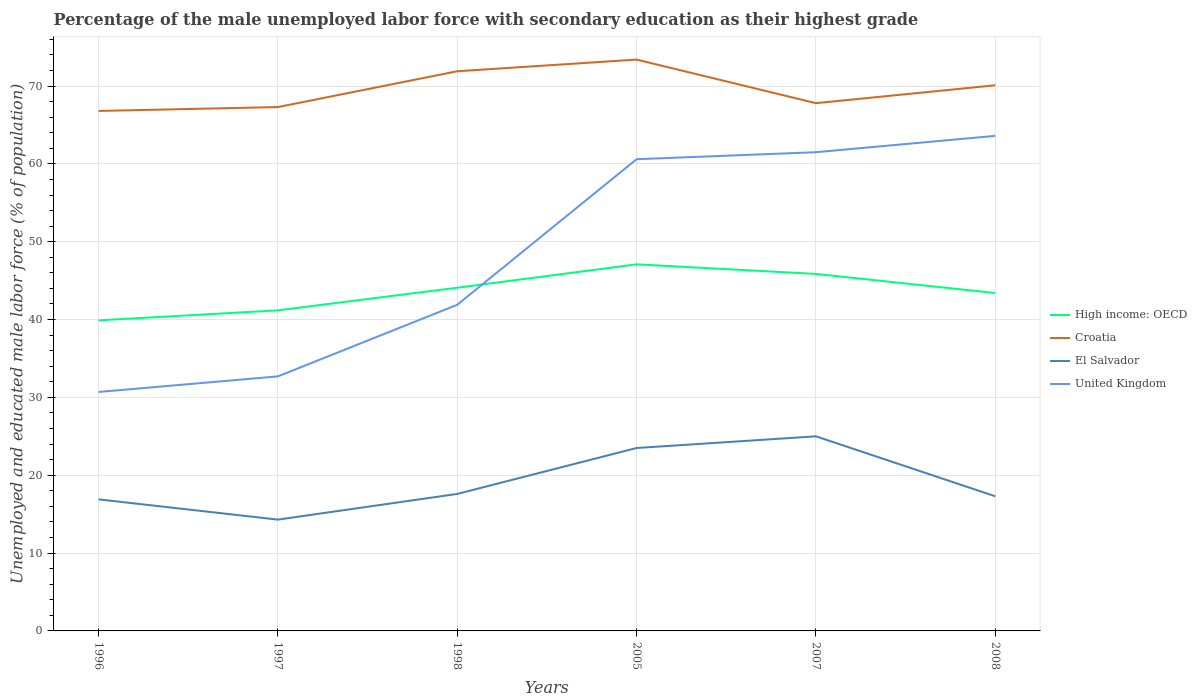How many different coloured lines are there?
Provide a short and direct response. 4. Does the line corresponding to High income: OECD intersect with the line corresponding to United Kingdom?
Your response must be concise. Yes. Is the number of lines equal to the number of legend labels?
Offer a very short reply. Yes. Across all years, what is the maximum percentage of the unemployed male labor force with secondary education in El Salvador?
Your answer should be compact. 14.3. What is the total percentage of the unemployed male labor force with secondary education in High income: OECD in the graph?
Ensure brevity in your answer.  -4.68. What is the difference between the highest and the second highest percentage of the unemployed male labor force with secondary education in High income: OECD?
Keep it short and to the point. 7.19. What is the difference between the highest and the lowest percentage of the unemployed male labor force with secondary education in United Kingdom?
Your answer should be compact. 3. How many lines are there?
Keep it short and to the point. 4. How many years are there in the graph?
Your answer should be compact. 6. Are the values on the major ticks of Y-axis written in scientific E-notation?
Your answer should be very brief. No. Does the graph contain grids?
Provide a short and direct response. Yes. How many legend labels are there?
Your answer should be compact. 4. How are the legend labels stacked?
Keep it short and to the point. Vertical. What is the title of the graph?
Offer a terse response. Percentage of the male unemployed labor force with secondary education as their highest grade. What is the label or title of the Y-axis?
Provide a short and direct response. Unemployed and educated male labor force (% of population). What is the Unemployed and educated male labor force (% of population) in High income: OECD in 1996?
Make the answer very short. 39.9. What is the Unemployed and educated male labor force (% of population) of Croatia in 1996?
Make the answer very short. 66.8. What is the Unemployed and educated male labor force (% of population) of El Salvador in 1996?
Make the answer very short. 16.9. What is the Unemployed and educated male labor force (% of population) in United Kingdom in 1996?
Your response must be concise. 30.7. What is the Unemployed and educated male labor force (% of population) in High income: OECD in 1997?
Offer a very short reply. 41.18. What is the Unemployed and educated male labor force (% of population) in Croatia in 1997?
Your answer should be compact. 67.3. What is the Unemployed and educated male labor force (% of population) in El Salvador in 1997?
Provide a succinct answer. 14.3. What is the Unemployed and educated male labor force (% of population) in United Kingdom in 1997?
Your answer should be very brief. 32.7. What is the Unemployed and educated male labor force (% of population) in High income: OECD in 1998?
Give a very brief answer. 44.09. What is the Unemployed and educated male labor force (% of population) in Croatia in 1998?
Keep it short and to the point. 71.9. What is the Unemployed and educated male labor force (% of population) of El Salvador in 1998?
Provide a short and direct response. 17.6. What is the Unemployed and educated male labor force (% of population) in United Kingdom in 1998?
Make the answer very short. 41.9. What is the Unemployed and educated male labor force (% of population) in High income: OECD in 2005?
Make the answer very short. 47.1. What is the Unemployed and educated male labor force (% of population) of Croatia in 2005?
Ensure brevity in your answer.  73.4. What is the Unemployed and educated male labor force (% of population) in El Salvador in 2005?
Provide a succinct answer. 23.5. What is the Unemployed and educated male labor force (% of population) of United Kingdom in 2005?
Ensure brevity in your answer.  60.6. What is the Unemployed and educated male labor force (% of population) of High income: OECD in 2007?
Give a very brief answer. 45.86. What is the Unemployed and educated male labor force (% of population) in Croatia in 2007?
Keep it short and to the point. 67.8. What is the Unemployed and educated male labor force (% of population) of United Kingdom in 2007?
Your answer should be very brief. 61.5. What is the Unemployed and educated male labor force (% of population) of High income: OECD in 2008?
Keep it short and to the point. 43.41. What is the Unemployed and educated male labor force (% of population) in Croatia in 2008?
Your answer should be very brief. 70.1. What is the Unemployed and educated male labor force (% of population) of El Salvador in 2008?
Make the answer very short. 17.3. What is the Unemployed and educated male labor force (% of population) in United Kingdom in 2008?
Offer a terse response. 63.6. Across all years, what is the maximum Unemployed and educated male labor force (% of population) in High income: OECD?
Keep it short and to the point. 47.1. Across all years, what is the maximum Unemployed and educated male labor force (% of population) in Croatia?
Your answer should be compact. 73.4. Across all years, what is the maximum Unemployed and educated male labor force (% of population) of United Kingdom?
Offer a very short reply. 63.6. Across all years, what is the minimum Unemployed and educated male labor force (% of population) of High income: OECD?
Keep it short and to the point. 39.9. Across all years, what is the minimum Unemployed and educated male labor force (% of population) of Croatia?
Your response must be concise. 66.8. Across all years, what is the minimum Unemployed and educated male labor force (% of population) in El Salvador?
Provide a succinct answer. 14.3. Across all years, what is the minimum Unemployed and educated male labor force (% of population) of United Kingdom?
Keep it short and to the point. 30.7. What is the total Unemployed and educated male labor force (% of population) of High income: OECD in the graph?
Your response must be concise. 261.55. What is the total Unemployed and educated male labor force (% of population) in Croatia in the graph?
Your response must be concise. 417.3. What is the total Unemployed and educated male labor force (% of population) of El Salvador in the graph?
Your answer should be very brief. 114.6. What is the total Unemployed and educated male labor force (% of population) of United Kingdom in the graph?
Your answer should be compact. 291. What is the difference between the Unemployed and educated male labor force (% of population) in High income: OECD in 1996 and that in 1997?
Give a very brief answer. -1.28. What is the difference between the Unemployed and educated male labor force (% of population) in El Salvador in 1996 and that in 1997?
Your answer should be compact. 2.6. What is the difference between the Unemployed and educated male labor force (% of population) in United Kingdom in 1996 and that in 1997?
Your answer should be compact. -2. What is the difference between the Unemployed and educated male labor force (% of population) in High income: OECD in 1996 and that in 1998?
Provide a short and direct response. -4.19. What is the difference between the Unemployed and educated male labor force (% of population) in Croatia in 1996 and that in 1998?
Ensure brevity in your answer.  -5.1. What is the difference between the Unemployed and educated male labor force (% of population) in High income: OECD in 1996 and that in 2005?
Keep it short and to the point. -7.19. What is the difference between the Unemployed and educated male labor force (% of population) in Croatia in 1996 and that in 2005?
Offer a very short reply. -6.6. What is the difference between the Unemployed and educated male labor force (% of population) in El Salvador in 1996 and that in 2005?
Offer a terse response. -6.6. What is the difference between the Unemployed and educated male labor force (% of population) in United Kingdom in 1996 and that in 2005?
Ensure brevity in your answer.  -29.9. What is the difference between the Unemployed and educated male labor force (% of population) in High income: OECD in 1996 and that in 2007?
Provide a succinct answer. -5.96. What is the difference between the Unemployed and educated male labor force (% of population) in Croatia in 1996 and that in 2007?
Give a very brief answer. -1. What is the difference between the Unemployed and educated male labor force (% of population) of El Salvador in 1996 and that in 2007?
Offer a very short reply. -8.1. What is the difference between the Unemployed and educated male labor force (% of population) in United Kingdom in 1996 and that in 2007?
Your answer should be very brief. -30.8. What is the difference between the Unemployed and educated male labor force (% of population) in High income: OECD in 1996 and that in 2008?
Your answer should be compact. -3.51. What is the difference between the Unemployed and educated male labor force (% of population) in Croatia in 1996 and that in 2008?
Provide a succinct answer. -3.3. What is the difference between the Unemployed and educated male labor force (% of population) in United Kingdom in 1996 and that in 2008?
Provide a succinct answer. -32.9. What is the difference between the Unemployed and educated male labor force (% of population) of High income: OECD in 1997 and that in 1998?
Your response must be concise. -2.91. What is the difference between the Unemployed and educated male labor force (% of population) in Croatia in 1997 and that in 1998?
Give a very brief answer. -4.6. What is the difference between the Unemployed and educated male labor force (% of population) in El Salvador in 1997 and that in 1998?
Give a very brief answer. -3.3. What is the difference between the Unemployed and educated male labor force (% of population) in United Kingdom in 1997 and that in 1998?
Make the answer very short. -9.2. What is the difference between the Unemployed and educated male labor force (% of population) in High income: OECD in 1997 and that in 2005?
Give a very brief answer. -5.91. What is the difference between the Unemployed and educated male labor force (% of population) of El Salvador in 1997 and that in 2005?
Your response must be concise. -9.2. What is the difference between the Unemployed and educated male labor force (% of population) in United Kingdom in 1997 and that in 2005?
Your answer should be very brief. -27.9. What is the difference between the Unemployed and educated male labor force (% of population) in High income: OECD in 1997 and that in 2007?
Your answer should be compact. -4.68. What is the difference between the Unemployed and educated male labor force (% of population) of El Salvador in 1997 and that in 2007?
Make the answer very short. -10.7. What is the difference between the Unemployed and educated male labor force (% of population) of United Kingdom in 1997 and that in 2007?
Provide a short and direct response. -28.8. What is the difference between the Unemployed and educated male labor force (% of population) in High income: OECD in 1997 and that in 2008?
Keep it short and to the point. -2.23. What is the difference between the Unemployed and educated male labor force (% of population) in El Salvador in 1997 and that in 2008?
Provide a short and direct response. -3. What is the difference between the Unemployed and educated male labor force (% of population) in United Kingdom in 1997 and that in 2008?
Offer a very short reply. -30.9. What is the difference between the Unemployed and educated male labor force (% of population) in High income: OECD in 1998 and that in 2005?
Your response must be concise. -3. What is the difference between the Unemployed and educated male labor force (% of population) of United Kingdom in 1998 and that in 2005?
Your answer should be compact. -18.7. What is the difference between the Unemployed and educated male labor force (% of population) of High income: OECD in 1998 and that in 2007?
Ensure brevity in your answer.  -1.77. What is the difference between the Unemployed and educated male labor force (% of population) in United Kingdom in 1998 and that in 2007?
Make the answer very short. -19.6. What is the difference between the Unemployed and educated male labor force (% of population) of High income: OECD in 1998 and that in 2008?
Provide a succinct answer. 0.68. What is the difference between the Unemployed and educated male labor force (% of population) in El Salvador in 1998 and that in 2008?
Keep it short and to the point. 0.3. What is the difference between the Unemployed and educated male labor force (% of population) in United Kingdom in 1998 and that in 2008?
Keep it short and to the point. -21.7. What is the difference between the Unemployed and educated male labor force (% of population) in High income: OECD in 2005 and that in 2007?
Offer a terse response. 1.23. What is the difference between the Unemployed and educated male labor force (% of population) of Croatia in 2005 and that in 2007?
Make the answer very short. 5.6. What is the difference between the Unemployed and educated male labor force (% of population) of El Salvador in 2005 and that in 2007?
Your answer should be very brief. -1.5. What is the difference between the Unemployed and educated male labor force (% of population) in United Kingdom in 2005 and that in 2007?
Provide a succinct answer. -0.9. What is the difference between the Unemployed and educated male labor force (% of population) of High income: OECD in 2005 and that in 2008?
Provide a succinct answer. 3.68. What is the difference between the Unemployed and educated male labor force (% of population) in El Salvador in 2005 and that in 2008?
Ensure brevity in your answer.  6.2. What is the difference between the Unemployed and educated male labor force (% of population) of United Kingdom in 2005 and that in 2008?
Provide a short and direct response. -3. What is the difference between the Unemployed and educated male labor force (% of population) in High income: OECD in 2007 and that in 2008?
Provide a short and direct response. 2.45. What is the difference between the Unemployed and educated male labor force (% of population) in El Salvador in 2007 and that in 2008?
Give a very brief answer. 7.7. What is the difference between the Unemployed and educated male labor force (% of population) in High income: OECD in 1996 and the Unemployed and educated male labor force (% of population) in Croatia in 1997?
Make the answer very short. -27.4. What is the difference between the Unemployed and educated male labor force (% of population) of High income: OECD in 1996 and the Unemployed and educated male labor force (% of population) of El Salvador in 1997?
Your response must be concise. 25.6. What is the difference between the Unemployed and educated male labor force (% of population) of High income: OECD in 1996 and the Unemployed and educated male labor force (% of population) of United Kingdom in 1997?
Provide a succinct answer. 7.2. What is the difference between the Unemployed and educated male labor force (% of population) of Croatia in 1996 and the Unemployed and educated male labor force (% of population) of El Salvador in 1997?
Provide a short and direct response. 52.5. What is the difference between the Unemployed and educated male labor force (% of population) in Croatia in 1996 and the Unemployed and educated male labor force (% of population) in United Kingdom in 1997?
Ensure brevity in your answer.  34.1. What is the difference between the Unemployed and educated male labor force (% of population) of El Salvador in 1996 and the Unemployed and educated male labor force (% of population) of United Kingdom in 1997?
Your answer should be compact. -15.8. What is the difference between the Unemployed and educated male labor force (% of population) of High income: OECD in 1996 and the Unemployed and educated male labor force (% of population) of Croatia in 1998?
Your answer should be compact. -32. What is the difference between the Unemployed and educated male labor force (% of population) in High income: OECD in 1996 and the Unemployed and educated male labor force (% of population) in El Salvador in 1998?
Provide a succinct answer. 22.3. What is the difference between the Unemployed and educated male labor force (% of population) of High income: OECD in 1996 and the Unemployed and educated male labor force (% of population) of United Kingdom in 1998?
Keep it short and to the point. -2. What is the difference between the Unemployed and educated male labor force (% of population) in Croatia in 1996 and the Unemployed and educated male labor force (% of population) in El Salvador in 1998?
Make the answer very short. 49.2. What is the difference between the Unemployed and educated male labor force (% of population) in Croatia in 1996 and the Unemployed and educated male labor force (% of population) in United Kingdom in 1998?
Provide a short and direct response. 24.9. What is the difference between the Unemployed and educated male labor force (% of population) in El Salvador in 1996 and the Unemployed and educated male labor force (% of population) in United Kingdom in 1998?
Offer a terse response. -25. What is the difference between the Unemployed and educated male labor force (% of population) of High income: OECD in 1996 and the Unemployed and educated male labor force (% of population) of Croatia in 2005?
Make the answer very short. -33.5. What is the difference between the Unemployed and educated male labor force (% of population) of High income: OECD in 1996 and the Unemployed and educated male labor force (% of population) of El Salvador in 2005?
Make the answer very short. 16.4. What is the difference between the Unemployed and educated male labor force (% of population) in High income: OECD in 1996 and the Unemployed and educated male labor force (% of population) in United Kingdom in 2005?
Your answer should be very brief. -20.7. What is the difference between the Unemployed and educated male labor force (% of population) of Croatia in 1996 and the Unemployed and educated male labor force (% of population) of El Salvador in 2005?
Your response must be concise. 43.3. What is the difference between the Unemployed and educated male labor force (% of population) of Croatia in 1996 and the Unemployed and educated male labor force (% of population) of United Kingdom in 2005?
Your answer should be very brief. 6.2. What is the difference between the Unemployed and educated male labor force (% of population) of El Salvador in 1996 and the Unemployed and educated male labor force (% of population) of United Kingdom in 2005?
Offer a terse response. -43.7. What is the difference between the Unemployed and educated male labor force (% of population) in High income: OECD in 1996 and the Unemployed and educated male labor force (% of population) in Croatia in 2007?
Provide a short and direct response. -27.9. What is the difference between the Unemployed and educated male labor force (% of population) in High income: OECD in 1996 and the Unemployed and educated male labor force (% of population) in El Salvador in 2007?
Ensure brevity in your answer.  14.9. What is the difference between the Unemployed and educated male labor force (% of population) in High income: OECD in 1996 and the Unemployed and educated male labor force (% of population) in United Kingdom in 2007?
Provide a short and direct response. -21.6. What is the difference between the Unemployed and educated male labor force (% of population) in Croatia in 1996 and the Unemployed and educated male labor force (% of population) in El Salvador in 2007?
Keep it short and to the point. 41.8. What is the difference between the Unemployed and educated male labor force (% of population) in El Salvador in 1996 and the Unemployed and educated male labor force (% of population) in United Kingdom in 2007?
Your answer should be compact. -44.6. What is the difference between the Unemployed and educated male labor force (% of population) of High income: OECD in 1996 and the Unemployed and educated male labor force (% of population) of Croatia in 2008?
Your answer should be compact. -30.2. What is the difference between the Unemployed and educated male labor force (% of population) in High income: OECD in 1996 and the Unemployed and educated male labor force (% of population) in El Salvador in 2008?
Provide a succinct answer. 22.6. What is the difference between the Unemployed and educated male labor force (% of population) in High income: OECD in 1996 and the Unemployed and educated male labor force (% of population) in United Kingdom in 2008?
Your response must be concise. -23.7. What is the difference between the Unemployed and educated male labor force (% of population) in Croatia in 1996 and the Unemployed and educated male labor force (% of population) in El Salvador in 2008?
Your answer should be very brief. 49.5. What is the difference between the Unemployed and educated male labor force (% of population) of El Salvador in 1996 and the Unemployed and educated male labor force (% of population) of United Kingdom in 2008?
Offer a terse response. -46.7. What is the difference between the Unemployed and educated male labor force (% of population) of High income: OECD in 1997 and the Unemployed and educated male labor force (% of population) of Croatia in 1998?
Provide a succinct answer. -30.72. What is the difference between the Unemployed and educated male labor force (% of population) in High income: OECD in 1997 and the Unemployed and educated male labor force (% of population) in El Salvador in 1998?
Keep it short and to the point. 23.58. What is the difference between the Unemployed and educated male labor force (% of population) of High income: OECD in 1997 and the Unemployed and educated male labor force (% of population) of United Kingdom in 1998?
Offer a very short reply. -0.72. What is the difference between the Unemployed and educated male labor force (% of population) in Croatia in 1997 and the Unemployed and educated male labor force (% of population) in El Salvador in 1998?
Your answer should be compact. 49.7. What is the difference between the Unemployed and educated male labor force (% of population) of Croatia in 1997 and the Unemployed and educated male labor force (% of population) of United Kingdom in 1998?
Offer a terse response. 25.4. What is the difference between the Unemployed and educated male labor force (% of population) in El Salvador in 1997 and the Unemployed and educated male labor force (% of population) in United Kingdom in 1998?
Provide a short and direct response. -27.6. What is the difference between the Unemployed and educated male labor force (% of population) of High income: OECD in 1997 and the Unemployed and educated male labor force (% of population) of Croatia in 2005?
Your response must be concise. -32.22. What is the difference between the Unemployed and educated male labor force (% of population) in High income: OECD in 1997 and the Unemployed and educated male labor force (% of population) in El Salvador in 2005?
Offer a very short reply. 17.68. What is the difference between the Unemployed and educated male labor force (% of population) in High income: OECD in 1997 and the Unemployed and educated male labor force (% of population) in United Kingdom in 2005?
Your response must be concise. -19.42. What is the difference between the Unemployed and educated male labor force (% of population) in Croatia in 1997 and the Unemployed and educated male labor force (% of population) in El Salvador in 2005?
Keep it short and to the point. 43.8. What is the difference between the Unemployed and educated male labor force (% of population) of Croatia in 1997 and the Unemployed and educated male labor force (% of population) of United Kingdom in 2005?
Offer a very short reply. 6.7. What is the difference between the Unemployed and educated male labor force (% of population) in El Salvador in 1997 and the Unemployed and educated male labor force (% of population) in United Kingdom in 2005?
Your answer should be very brief. -46.3. What is the difference between the Unemployed and educated male labor force (% of population) of High income: OECD in 1997 and the Unemployed and educated male labor force (% of population) of Croatia in 2007?
Make the answer very short. -26.62. What is the difference between the Unemployed and educated male labor force (% of population) in High income: OECD in 1997 and the Unemployed and educated male labor force (% of population) in El Salvador in 2007?
Your answer should be compact. 16.18. What is the difference between the Unemployed and educated male labor force (% of population) in High income: OECD in 1997 and the Unemployed and educated male labor force (% of population) in United Kingdom in 2007?
Your answer should be compact. -20.32. What is the difference between the Unemployed and educated male labor force (% of population) of Croatia in 1997 and the Unemployed and educated male labor force (% of population) of El Salvador in 2007?
Offer a very short reply. 42.3. What is the difference between the Unemployed and educated male labor force (% of population) in Croatia in 1997 and the Unemployed and educated male labor force (% of population) in United Kingdom in 2007?
Your answer should be compact. 5.8. What is the difference between the Unemployed and educated male labor force (% of population) in El Salvador in 1997 and the Unemployed and educated male labor force (% of population) in United Kingdom in 2007?
Keep it short and to the point. -47.2. What is the difference between the Unemployed and educated male labor force (% of population) of High income: OECD in 1997 and the Unemployed and educated male labor force (% of population) of Croatia in 2008?
Ensure brevity in your answer.  -28.92. What is the difference between the Unemployed and educated male labor force (% of population) of High income: OECD in 1997 and the Unemployed and educated male labor force (% of population) of El Salvador in 2008?
Your answer should be compact. 23.88. What is the difference between the Unemployed and educated male labor force (% of population) of High income: OECD in 1997 and the Unemployed and educated male labor force (% of population) of United Kingdom in 2008?
Keep it short and to the point. -22.42. What is the difference between the Unemployed and educated male labor force (% of population) of El Salvador in 1997 and the Unemployed and educated male labor force (% of population) of United Kingdom in 2008?
Offer a very short reply. -49.3. What is the difference between the Unemployed and educated male labor force (% of population) of High income: OECD in 1998 and the Unemployed and educated male labor force (% of population) of Croatia in 2005?
Provide a short and direct response. -29.31. What is the difference between the Unemployed and educated male labor force (% of population) of High income: OECD in 1998 and the Unemployed and educated male labor force (% of population) of El Salvador in 2005?
Provide a short and direct response. 20.59. What is the difference between the Unemployed and educated male labor force (% of population) of High income: OECD in 1998 and the Unemployed and educated male labor force (% of population) of United Kingdom in 2005?
Offer a terse response. -16.51. What is the difference between the Unemployed and educated male labor force (% of population) of Croatia in 1998 and the Unemployed and educated male labor force (% of population) of El Salvador in 2005?
Give a very brief answer. 48.4. What is the difference between the Unemployed and educated male labor force (% of population) of Croatia in 1998 and the Unemployed and educated male labor force (% of population) of United Kingdom in 2005?
Provide a succinct answer. 11.3. What is the difference between the Unemployed and educated male labor force (% of population) of El Salvador in 1998 and the Unemployed and educated male labor force (% of population) of United Kingdom in 2005?
Offer a very short reply. -43. What is the difference between the Unemployed and educated male labor force (% of population) in High income: OECD in 1998 and the Unemployed and educated male labor force (% of population) in Croatia in 2007?
Your answer should be compact. -23.71. What is the difference between the Unemployed and educated male labor force (% of population) of High income: OECD in 1998 and the Unemployed and educated male labor force (% of population) of El Salvador in 2007?
Make the answer very short. 19.09. What is the difference between the Unemployed and educated male labor force (% of population) of High income: OECD in 1998 and the Unemployed and educated male labor force (% of population) of United Kingdom in 2007?
Provide a succinct answer. -17.41. What is the difference between the Unemployed and educated male labor force (% of population) in Croatia in 1998 and the Unemployed and educated male labor force (% of population) in El Salvador in 2007?
Keep it short and to the point. 46.9. What is the difference between the Unemployed and educated male labor force (% of population) of Croatia in 1998 and the Unemployed and educated male labor force (% of population) of United Kingdom in 2007?
Make the answer very short. 10.4. What is the difference between the Unemployed and educated male labor force (% of population) in El Salvador in 1998 and the Unemployed and educated male labor force (% of population) in United Kingdom in 2007?
Offer a terse response. -43.9. What is the difference between the Unemployed and educated male labor force (% of population) in High income: OECD in 1998 and the Unemployed and educated male labor force (% of population) in Croatia in 2008?
Give a very brief answer. -26.01. What is the difference between the Unemployed and educated male labor force (% of population) of High income: OECD in 1998 and the Unemployed and educated male labor force (% of population) of El Salvador in 2008?
Ensure brevity in your answer.  26.79. What is the difference between the Unemployed and educated male labor force (% of population) of High income: OECD in 1998 and the Unemployed and educated male labor force (% of population) of United Kingdom in 2008?
Offer a terse response. -19.51. What is the difference between the Unemployed and educated male labor force (% of population) in Croatia in 1998 and the Unemployed and educated male labor force (% of population) in El Salvador in 2008?
Ensure brevity in your answer.  54.6. What is the difference between the Unemployed and educated male labor force (% of population) of El Salvador in 1998 and the Unemployed and educated male labor force (% of population) of United Kingdom in 2008?
Ensure brevity in your answer.  -46. What is the difference between the Unemployed and educated male labor force (% of population) in High income: OECD in 2005 and the Unemployed and educated male labor force (% of population) in Croatia in 2007?
Make the answer very short. -20.7. What is the difference between the Unemployed and educated male labor force (% of population) of High income: OECD in 2005 and the Unemployed and educated male labor force (% of population) of El Salvador in 2007?
Your answer should be compact. 22.09. What is the difference between the Unemployed and educated male labor force (% of population) in High income: OECD in 2005 and the Unemployed and educated male labor force (% of population) in United Kingdom in 2007?
Keep it short and to the point. -14.4. What is the difference between the Unemployed and educated male labor force (% of population) of Croatia in 2005 and the Unemployed and educated male labor force (% of population) of El Salvador in 2007?
Provide a succinct answer. 48.4. What is the difference between the Unemployed and educated male labor force (% of population) of Croatia in 2005 and the Unemployed and educated male labor force (% of population) of United Kingdom in 2007?
Provide a succinct answer. 11.9. What is the difference between the Unemployed and educated male labor force (% of population) in El Salvador in 2005 and the Unemployed and educated male labor force (% of population) in United Kingdom in 2007?
Keep it short and to the point. -38. What is the difference between the Unemployed and educated male labor force (% of population) of High income: OECD in 2005 and the Unemployed and educated male labor force (% of population) of Croatia in 2008?
Your answer should be compact. -23. What is the difference between the Unemployed and educated male labor force (% of population) of High income: OECD in 2005 and the Unemployed and educated male labor force (% of population) of El Salvador in 2008?
Offer a terse response. 29.8. What is the difference between the Unemployed and educated male labor force (% of population) in High income: OECD in 2005 and the Unemployed and educated male labor force (% of population) in United Kingdom in 2008?
Keep it short and to the point. -16.5. What is the difference between the Unemployed and educated male labor force (% of population) in Croatia in 2005 and the Unemployed and educated male labor force (% of population) in El Salvador in 2008?
Ensure brevity in your answer.  56.1. What is the difference between the Unemployed and educated male labor force (% of population) in Croatia in 2005 and the Unemployed and educated male labor force (% of population) in United Kingdom in 2008?
Ensure brevity in your answer.  9.8. What is the difference between the Unemployed and educated male labor force (% of population) in El Salvador in 2005 and the Unemployed and educated male labor force (% of population) in United Kingdom in 2008?
Make the answer very short. -40.1. What is the difference between the Unemployed and educated male labor force (% of population) of High income: OECD in 2007 and the Unemployed and educated male labor force (% of population) of Croatia in 2008?
Make the answer very short. -24.24. What is the difference between the Unemployed and educated male labor force (% of population) in High income: OECD in 2007 and the Unemployed and educated male labor force (% of population) in El Salvador in 2008?
Provide a succinct answer. 28.56. What is the difference between the Unemployed and educated male labor force (% of population) of High income: OECD in 2007 and the Unemployed and educated male labor force (% of population) of United Kingdom in 2008?
Give a very brief answer. -17.74. What is the difference between the Unemployed and educated male labor force (% of population) in Croatia in 2007 and the Unemployed and educated male labor force (% of population) in El Salvador in 2008?
Your answer should be compact. 50.5. What is the difference between the Unemployed and educated male labor force (% of population) in El Salvador in 2007 and the Unemployed and educated male labor force (% of population) in United Kingdom in 2008?
Provide a succinct answer. -38.6. What is the average Unemployed and educated male labor force (% of population) in High income: OECD per year?
Provide a succinct answer. 43.59. What is the average Unemployed and educated male labor force (% of population) in Croatia per year?
Make the answer very short. 69.55. What is the average Unemployed and educated male labor force (% of population) of United Kingdom per year?
Your answer should be very brief. 48.5. In the year 1996, what is the difference between the Unemployed and educated male labor force (% of population) of High income: OECD and Unemployed and educated male labor force (% of population) of Croatia?
Your answer should be compact. -26.9. In the year 1996, what is the difference between the Unemployed and educated male labor force (% of population) in High income: OECD and Unemployed and educated male labor force (% of population) in El Salvador?
Give a very brief answer. 23. In the year 1996, what is the difference between the Unemployed and educated male labor force (% of population) in High income: OECD and Unemployed and educated male labor force (% of population) in United Kingdom?
Offer a terse response. 9.2. In the year 1996, what is the difference between the Unemployed and educated male labor force (% of population) of Croatia and Unemployed and educated male labor force (% of population) of El Salvador?
Provide a succinct answer. 49.9. In the year 1996, what is the difference between the Unemployed and educated male labor force (% of population) of Croatia and Unemployed and educated male labor force (% of population) of United Kingdom?
Your answer should be very brief. 36.1. In the year 1996, what is the difference between the Unemployed and educated male labor force (% of population) in El Salvador and Unemployed and educated male labor force (% of population) in United Kingdom?
Provide a succinct answer. -13.8. In the year 1997, what is the difference between the Unemployed and educated male labor force (% of population) of High income: OECD and Unemployed and educated male labor force (% of population) of Croatia?
Your answer should be very brief. -26.12. In the year 1997, what is the difference between the Unemployed and educated male labor force (% of population) in High income: OECD and Unemployed and educated male labor force (% of population) in El Salvador?
Your response must be concise. 26.88. In the year 1997, what is the difference between the Unemployed and educated male labor force (% of population) of High income: OECD and Unemployed and educated male labor force (% of population) of United Kingdom?
Offer a very short reply. 8.48. In the year 1997, what is the difference between the Unemployed and educated male labor force (% of population) of Croatia and Unemployed and educated male labor force (% of population) of United Kingdom?
Provide a short and direct response. 34.6. In the year 1997, what is the difference between the Unemployed and educated male labor force (% of population) of El Salvador and Unemployed and educated male labor force (% of population) of United Kingdom?
Your answer should be very brief. -18.4. In the year 1998, what is the difference between the Unemployed and educated male labor force (% of population) of High income: OECD and Unemployed and educated male labor force (% of population) of Croatia?
Provide a succinct answer. -27.81. In the year 1998, what is the difference between the Unemployed and educated male labor force (% of population) in High income: OECD and Unemployed and educated male labor force (% of population) in El Salvador?
Offer a terse response. 26.49. In the year 1998, what is the difference between the Unemployed and educated male labor force (% of population) of High income: OECD and Unemployed and educated male labor force (% of population) of United Kingdom?
Keep it short and to the point. 2.19. In the year 1998, what is the difference between the Unemployed and educated male labor force (% of population) of Croatia and Unemployed and educated male labor force (% of population) of El Salvador?
Make the answer very short. 54.3. In the year 1998, what is the difference between the Unemployed and educated male labor force (% of population) of Croatia and Unemployed and educated male labor force (% of population) of United Kingdom?
Provide a short and direct response. 30. In the year 1998, what is the difference between the Unemployed and educated male labor force (% of population) in El Salvador and Unemployed and educated male labor force (% of population) in United Kingdom?
Offer a very short reply. -24.3. In the year 2005, what is the difference between the Unemployed and educated male labor force (% of population) in High income: OECD and Unemployed and educated male labor force (% of population) in Croatia?
Provide a short and direct response. -26.3. In the year 2005, what is the difference between the Unemployed and educated male labor force (% of population) of High income: OECD and Unemployed and educated male labor force (% of population) of El Salvador?
Give a very brief answer. 23.59. In the year 2005, what is the difference between the Unemployed and educated male labor force (% of population) in High income: OECD and Unemployed and educated male labor force (% of population) in United Kingdom?
Provide a succinct answer. -13.51. In the year 2005, what is the difference between the Unemployed and educated male labor force (% of population) of Croatia and Unemployed and educated male labor force (% of population) of El Salvador?
Offer a terse response. 49.9. In the year 2005, what is the difference between the Unemployed and educated male labor force (% of population) in Croatia and Unemployed and educated male labor force (% of population) in United Kingdom?
Provide a short and direct response. 12.8. In the year 2005, what is the difference between the Unemployed and educated male labor force (% of population) in El Salvador and Unemployed and educated male labor force (% of population) in United Kingdom?
Provide a succinct answer. -37.1. In the year 2007, what is the difference between the Unemployed and educated male labor force (% of population) in High income: OECD and Unemployed and educated male labor force (% of population) in Croatia?
Offer a very short reply. -21.94. In the year 2007, what is the difference between the Unemployed and educated male labor force (% of population) of High income: OECD and Unemployed and educated male labor force (% of population) of El Salvador?
Ensure brevity in your answer.  20.86. In the year 2007, what is the difference between the Unemployed and educated male labor force (% of population) of High income: OECD and Unemployed and educated male labor force (% of population) of United Kingdom?
Give a very brief answer. -15.64. In the year 2007, what is the difference between the Unemployed and educated male labor force (% of population) in Croatia and Unemployed and educated male labor force (% of population) in El Salvador?
Your answer should be compact. 42.8. In the year 2007, what is the difference between the Unemployed and educated male labor force (% of population) in El Salvador and Unemployed and educated male labor force (% of population) in United Kingdom?
Keep it short and to the point. -36.5. In the year 2008, what is the difference between the Unemployed and educated male labor force (% of population) in High income: OECD and Unemployed and educated male labor force (% of population) in Croatia?
Your answer should be compact. -26.69. In the year 2008, what is the difference between the Unemployed and educated male labor force (% of population) in High income: OECD and Unemployed and educated male labor force (% of population) in El Salvador?
Your response must be concise. 26.11. In the year 2008, what is the difference between the Unemployed and educated male labor force (% of population) in High income: OECD and Unemployed and educated male labor force (% of population) in United Kingdom?
Keep it short and to the point. -20.19. In the year 2008, what is the difference between the Unemployed and educated male labor force (% of population) in Croatia and Unemployed and educated male labor force (% of population) in El Salvador?
Offer a terse response. 52.8. In the year 2008, what is the difference between the Unemployed and educated male labor force (% of population) of Croatia and Unemployed and educated male labor force (% of population) of United Kingdom?
Offer a very short reply. 6.5. In the year 2008, what is the difference between the Unemployed and educated male labor force (% of population) of El Salvador and Unemployed and educated male labor force (% of population) of United Kingdom?
Your response must be concise. -46.3. What is the ratio of the Unemployed and educated male labor force (% of population) in High income: OECD in 1996 to that in 1997?
Your response must be concise. 0.97. What is the ratio of the Unemployed and educated male labor force (% of population) of El Salvador in 1996 to that in 1997?
Keep it short and to the point. 1.18. What is the ratio of the Unemployed and educated male labor force (% of population) of United Kingdom in 1996 to that in 1997?
Give a very brief answer. 0.94. What is the ratio of the Unemployed and educated male labor force (% of population) of High income: OECD in 1996 to that in 1998?
Your answer should be very brief. 0.91. What is the ratio of the Unemployed and educated male labor force (% of population) in Croatia in 1996 to that in 1998?
Offer a terse response. 0.93. What is the ratio of the Unemployed and educated male labor force (% of population) of El Salvador in 1996 to that in 1998?
Your answer should be compact. 0.96. What is the ratio of the Unemployed and educated male labor force (% of population) of United Kingdom in 1996 to that in 1998?
Provide a short and direct response. 0.73. What is the ratio of the Unemployed and educated male labor force (% of population) in High income: OECD in 1996 to that in 2005?
Offer a very short reply. 0.85. What is the ratio of the Unemployed and educated male labor force (% of population) of Croatia in 1996 to that in 2005?
Ensure brevity in your answer.  0.91. What is the ratio of the Unemployed and educated male labor force (% of population) of El Salvador in 1996 to that in 2005?
Ensure brevity in your answer.  0.72. What is the ratio of the Unemployed and educated male labor force (% of population) of United Kingdom in 1996 to that in 2005?
Make the answer very short. 0.51. What is the ratio of the Unemployed and educated male labor force (% of population) in High income: OECD in 1996 to that in 2007?
Ensure brevity in your answer.  0.87. What is the ratio of the Unemployed and educated male labor force (% of population) in El Salvador in 1996 to that in 2007?
Your answer should be very brief. 0.68. What is the ratio of the Unemployed and educated male labor force (% of population) in United Kingdom in 1996 to that in 2007?
Make the answer very short. 0.5. What is the ratio of the Unemployed and educated male labor force (% of population) in High income: OECD in 1996 to that in 2008?
Offer a terse response. 0.92. What is the ratio of the Unemployed and educated male labor force (% of population) in Croatia in 1996 to that in 2008?
Make the answer very short. 0.95. What is the ratio of the Unemployed and educated male labor force (% of population) of El Salvador in 1996 to that in 2008?
Keep it short and to the point. 0.98. What is the ratio of the Unemployed and educated male labor force (% of population) in United Kingdom in 1996 to that in 2008?
Offer a terse response. 0.48. What is the ratio of the Unemployed and educated male labor force (% of population) in High income: OECD in 1997 to that in 1998?
Your answer should be compact. 0.93. What is the ratio of the Unemployed and educated male labor force (% of population) of Croatia in 1997 to that in 1998?
Your response must be concise. 0.94. What is the ratio of the Unemployed and educated male labor force (% of population) of El Salvador in 1997 to that in 1998?
Your answer should be very brief. 0.81. What is the ratio of the Unemployed and educated male labor force (% of population) in United Kingdom in 1997 to that in 1998?
Ensure brevity in your answer.  0.78. What is the ratio of the Unemployed and educated male labor force (% of population) in High income: OECD in 1997 to that in 2005?
Keep it short and to the point. 0.87. What is the ratio of the Unemployed and educated male labor force (% of population) in Croatia in 1997 to that in 2005?
Give a very brief answer. 0.92. What is the ratio of the Unemployed and educated male labor force (% of population) of El Salvador in 1997 to that in 2005?
Offer a terse response. 0.61. What is the ratio of the Unemployed and educated male labor force (% of population) of United Kingdom in 1997 to that in 2005?
Make the answer very short. 0.54. What is the ratio of the Unemployed and educated male labor force (% of population) in High income: OECD in 1997 to that in 2007?
Provide a short and direct response. 0.9. What is the ratio of the Unemployed and educated male labor force (% of population) in Croatia in 1997 to that in 2007?
Give a very brief answer. 0.99. What is the ratio of the Unemployed and educated male labor force (% of population) in El Salvador in 1997 to that in 2007?
Give a very brief answer. 0.57. What is the ratio of the Unemployed and educated male labor force (% of population) of United Kingdom in 1997 to that in 2007?
Make the answer very short. 0.53. What is the ratio of the Unemployed and educated male labor force (% of population) of High income: OECD in 1997 to that in 2008?
Keep it short and to the point. 0.95. What is the ratio of the Unemployed and educated male labor force (% of population) in Croatia in 1997 to that in 2008?
Offer a very short reply. 0.96. What is the ratio of the Unemployed and educated male labor force (% of population) in El Salvador in 1997 to that in 2008?
Provide a succinct answer. 0.83. What is the ratio of the Unemployed and educated male labor force (% of population) in United Kingdom in 1997 to that in 2008?
Your answer should be compact. 0.51. What is the ratio of the Unemployed and educated male labor force (% of population) of High income: OECD in 1998 to that in 2005?
Give a very brief answer. 0.94. What is the ratio of the Unemployed and educated male labor force (% of population) in Croatia in 1998 to that in 2005?
Give a very brief answer. 0.98. What is the ratio of the Unemployed and educated male labor force (% of population) of El Salvador in 1998 to that in 2005?
Your answer should be very brief. 0.75. What is the ratio of the Unemployed and educated male labor force (% of population) of United Kingdom in 1998 to that in 2005?
Provide a succinct answer. 0.69. What is the ratio of the Unemployed and educated male labor force (% of population) of High income: OECD in 1998 to that in 2007?
Make the answer very short. 0.96. What is the ratio of the Unemployed and educated male labor force (% of population) in Croatia in 1998 to that in 2007?
Provide a succinct answer. 1.06. What is the ratio of the Unemployed and educated male labor force (% of population) of El Salvador in 1998 to that in 2007?
Provide a short and direct response. 0.7. What is the ratio of the Unemployed and educated male labor force (% of population) of United Kingdom in 1998 to that in 2007?
Provide a short and direct response. 0.68. What is the ratio of the Unemployed and educated male labor force (% of population) of High income: OECD in 1998 to that in 2008?
Offer a very short reply. 1.02. What is the ratio of the Unemployed and educated male labor force (% of population) of Croatia in 1998 to that in 2008?
Keep it short and to the point. 1.03. What is the ratio of the Unemployed and educated male labor force (% of population) in El Salvador in 1998 to that in 2008?
Provide a succinct answer. 1.02. What is the ratio of the Unemployed and educated male labor force (% of population) of United Kingdom in 1998 to that in 2008?
Provide a short and direct response. 0.66. What is the ratio of the Unemployed and educated male labor force (% of population) of High income: OECD in 2005 to that in 2007?
Offer a terse response. 1.03. What is the ratio of the Unemployed and educated male labor force (% of population) in Croatia in 2005 to that in 2007?
Provide a succinct answer. 1.08. What is the ratio of the Unemployed and educated male labor force (% of population) of El Salvador in 2005 to that in 2007?
Keep it short and to the point. 0.94. What is the ratio of the Unemployed and educated male labor force (% of population) of United Kingdom in 2005 to that in 2007?
Provide a succinct answer. 0.99. What is the ratio of the Unemployed and educated male labor force (% of population) in High income: OECD in 2005 to that in 2008?
Ensure brevity in your answer.  1.08. What is the ratio of the Unemployed and educated male labor force (% of population) of Croatia in 2005 to that in 2008?
Ensure brevity in your answer.  1.05. What is the ratio of the Unemployed and educated male labor force (% of population) of El Salvador in 2005 to that in 2008?
Your response must be concise. 1.36. What is the ratio of the Unemployed and educated male labor force (% of population) of United Kingdom in 2005 to that in 2008?
Provide a short and direct response. 0.95. What is the ratio of the Unemployed and educated male labor force (% of population) in High income: OECD in 2007 to that in 2008?
Keep it short and to the point. 1.06. What is the ratio of the Unemployed and educated male labor force (% of population) in Croatia in 2007 to that in 2008?
Offer a terse response. 0.97. What is the ratio of the Unemployed and educated male labor force (% of population) in El Salvador in 2007 to that in 2008?
Your response must be concise. 1.45. What is the difference between the highest and the second highest Unemployed and educated male labor force (% of population) of High income: OECD?
Offer a terse response. 1.23. What is the difference between the highest and the lowest Unemployed and educated male labor force (% of population) of High income: OECD?
Your answer should be very brief. 7.19. What is the difference between the highest and the lowest Unemployed and educated male labor force (% of population) in Croatia?
Provide a short and direct response. 6.6. What is the difference between the highest and the lowest Unemployed and educated male labor force (% of population) of United Kingdom?
Provide a succinct answer. 32.9. 